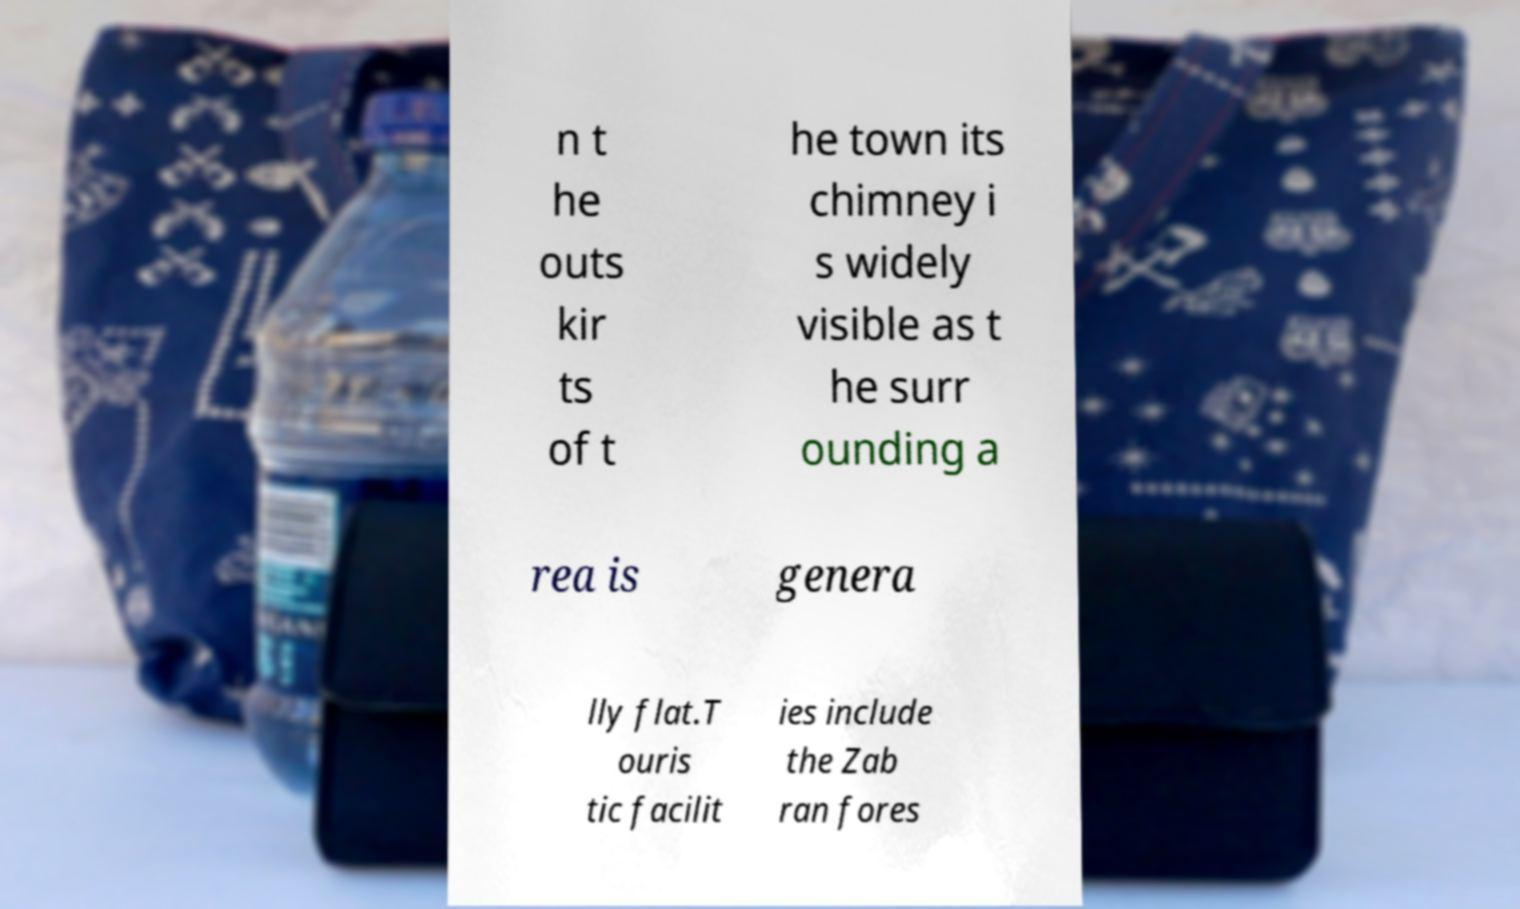What messages or text are displayed in this image? I need them in a readable, typed format. n t he outs kir ts of t he town its chimney i s widely visible as t he surr ounding a rea is genera lly flat.T ouris tic facilit ies include the Zab ran fores 